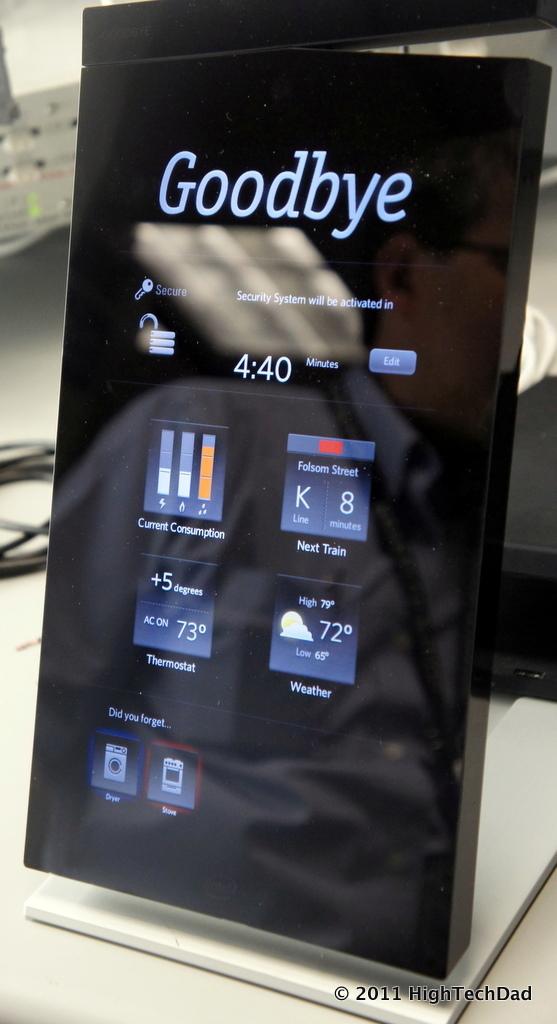What does it say on the top of the display?
Give a very brief answer. Goodbye. What time is it?
Your answer should be compact. 4:40. 